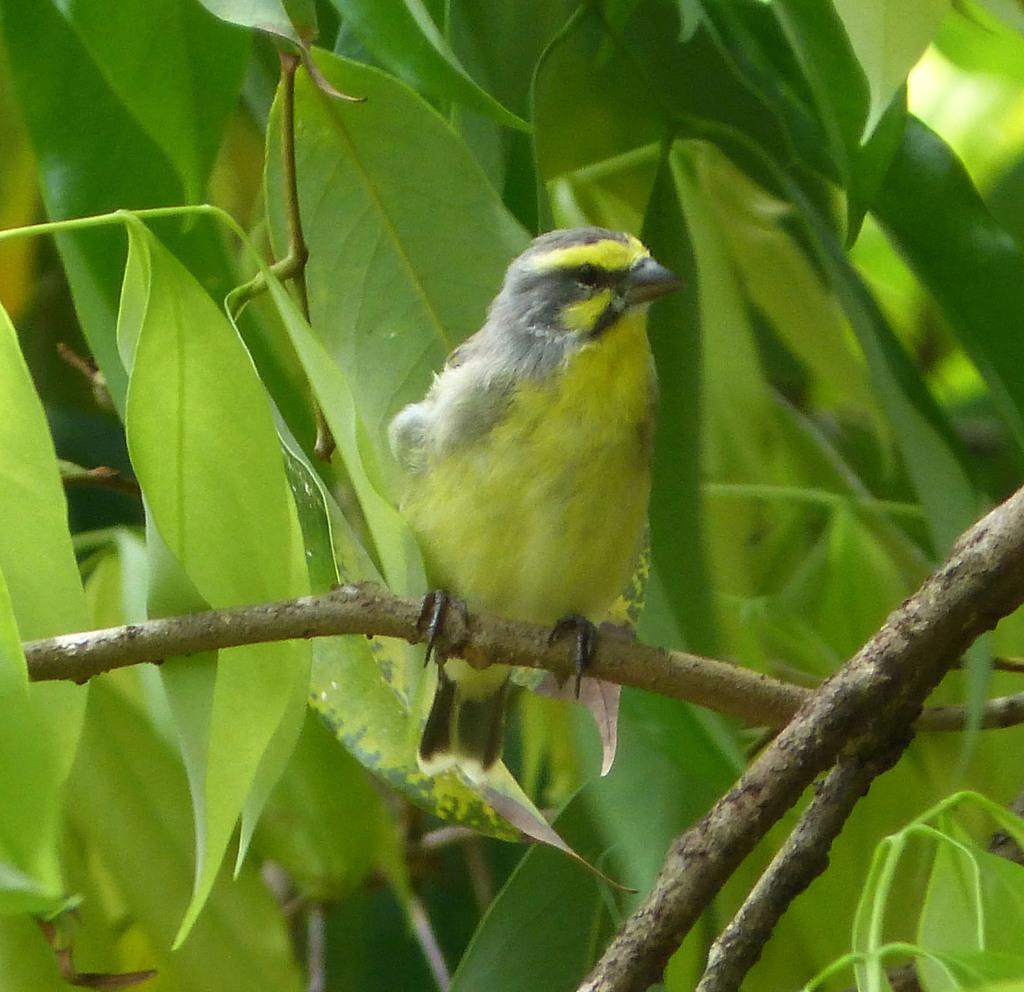Could you give a brief overview of what you see in this image? In this picture there is a bird in the center of the image, on the stem and there are leaves in the background area of the image. 